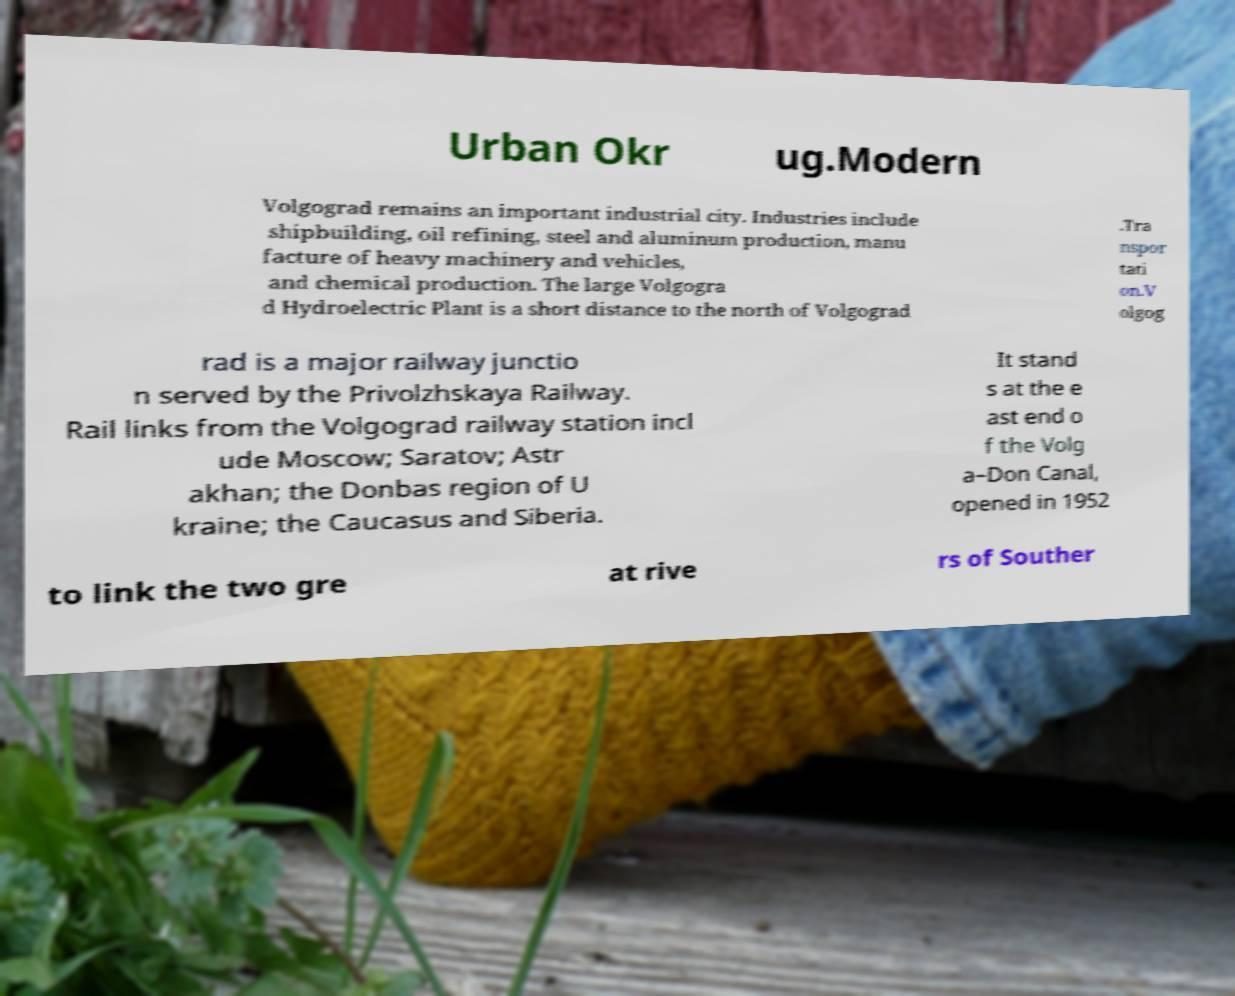Please read and relay the text visible in this image. What does it say? Urban Okr ug.Modern Volgograd remains an important industrial city. Industries include shipbuilding, oil refining, steel and aluminum production, manu facture of heavy machinery and vehicles, and chemical production. The large Volgogra d Hydroelectric Plant is a short distance to the north of Volgograd .Tra nspor tati on.V olgog rad is a major railway junctio n served by the Privolzhskaya Railway. Rail links from the Volgograd railway station incl ude Moscow; Saratov; Astr akhan; the Donbas region of U kraine; the Caucasus and Siberia. It stand s at the e ast end o f the Volg a–Don Canal, opened in 1952 to link the two gre at rive rs of Souther 